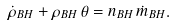Convert formula to latex. <formula><loc_0><loc_0><loc_500><loc_500>\dot { \rho } _ { B H } + \rho _ { B H } \, \theta = n _ { B H } \, \dot { m } _ { B H } .</formula> 